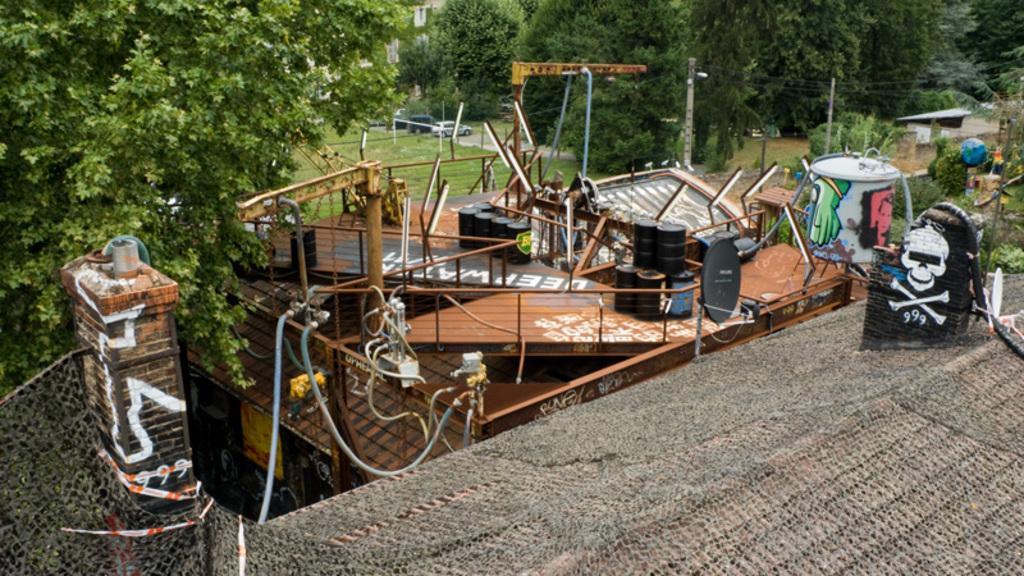How would you summarize this image in a sentence or two? In this image I can see building, few drawings, number of trees, few poles, few wires, few vehicles and here I can see number of black colour containers. 